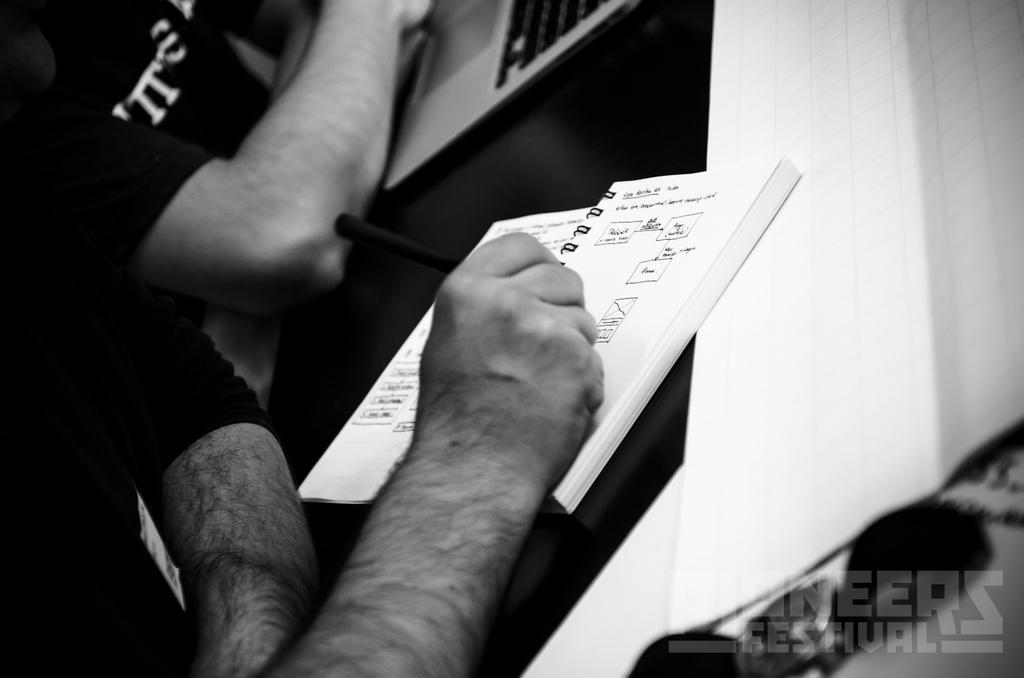How would you summarize this image in a sentence or two? In this picture there are two persons, among them one person holding a pen and we can see laptop and book on the table. In the bottom right side of the image we can see watermark. 